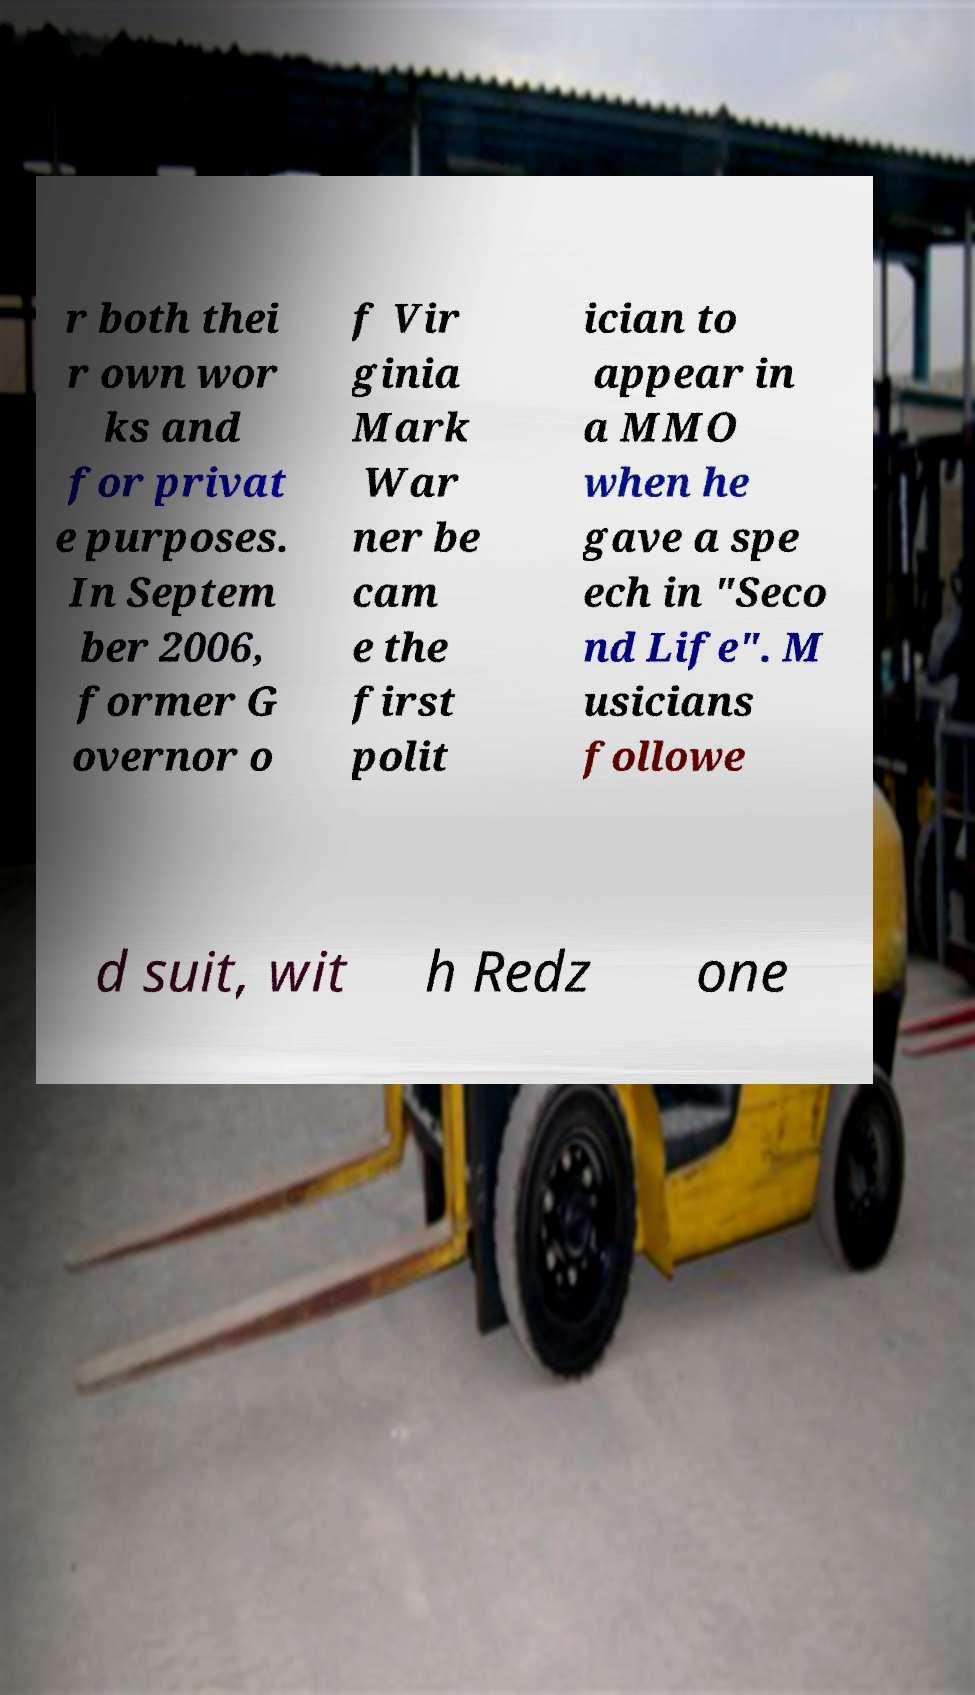Please identify and transcribe the text found in this image. r both thei r own wor ks and for privat e purposes. In Septem ber 2006, former G overnor o f Vir ginia Mark War ner be cam e the first polit ician to appear in a MMO when he gave a spe ech in "Seco nd Life". M usicians followe d suit, wit h Redz one 